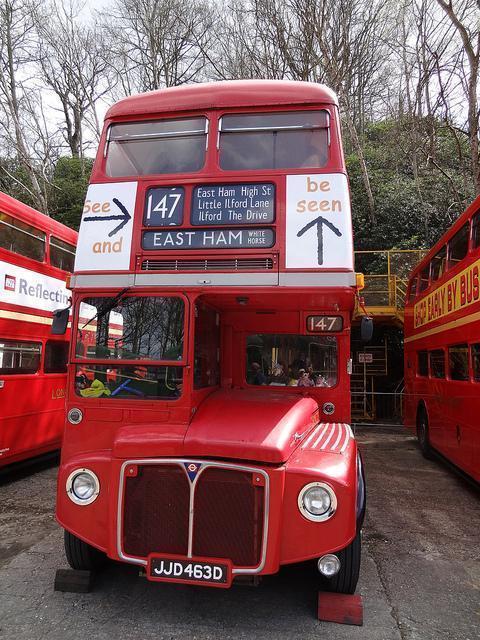What do the items in front of the tires here prevent?
Answer the question by selecting the correct answer among the 4 following choices.
Options: Reversals, speeding, rolling, advertising. Rolling. 